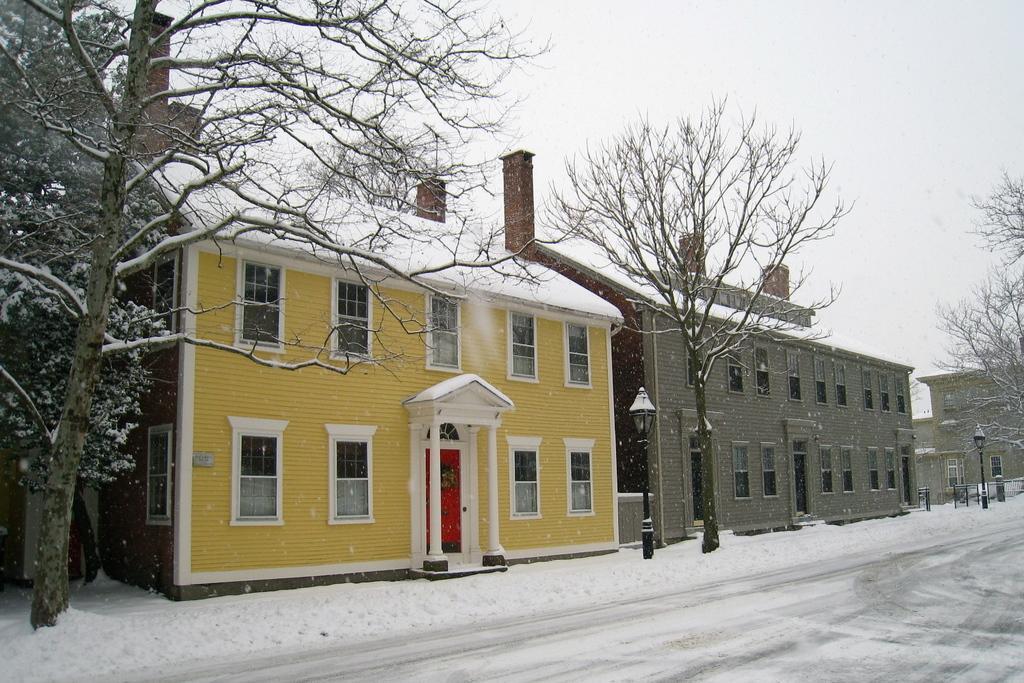Could you give a brief overview of what you see in this image? There is a road. Near to the road there are trees, street light poles and buildings with windows, pillars and door. And it is covered with snow. 